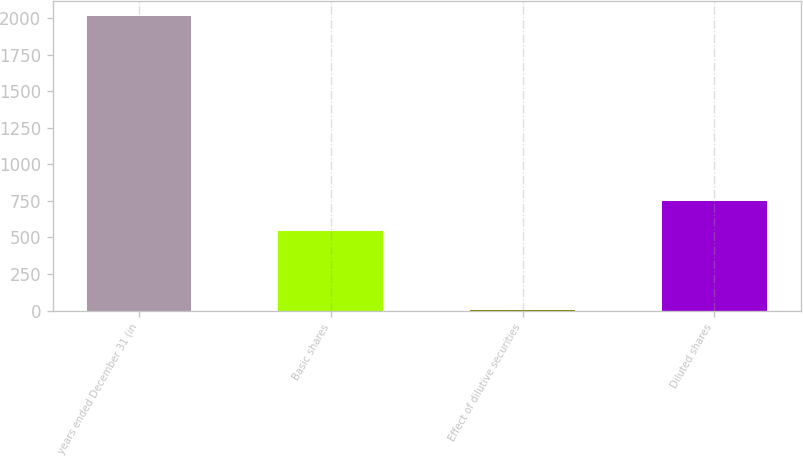Convert chart. <chart><loc_0><loc_0><loc_500><loc_500><bar_chart><fcel>years ended December 31 (in<fcel>Basic shares<fcel>Effect of dilutive securities<fcel>Diluted shares<nl><fcel>2015<fcel>545<fcel>4<fcel>746.1<nl></chart> 